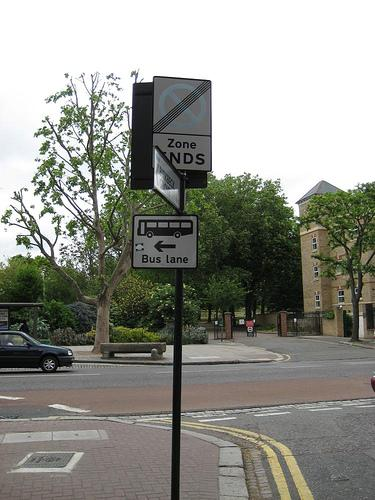What is the sign pointing to?

Choices:
A) toy boat
B) wrestler
C) baby
D) bus lane bus lane 